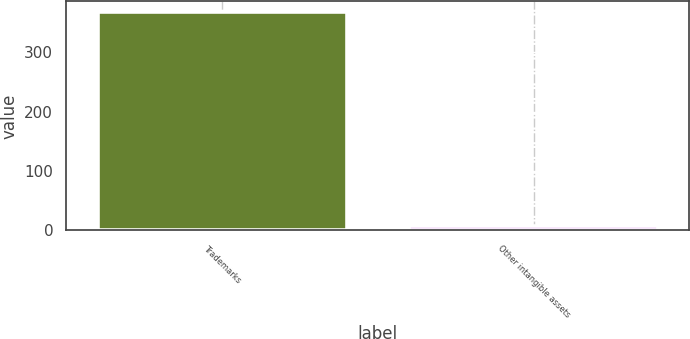<chart> <loc_0><loc_0><loc_500><loc_500><bar_chart><fcel>Trademarks<fcel>Other intangible assets<nl><fcel>367.1<fcel>7.8<nl></chart> 